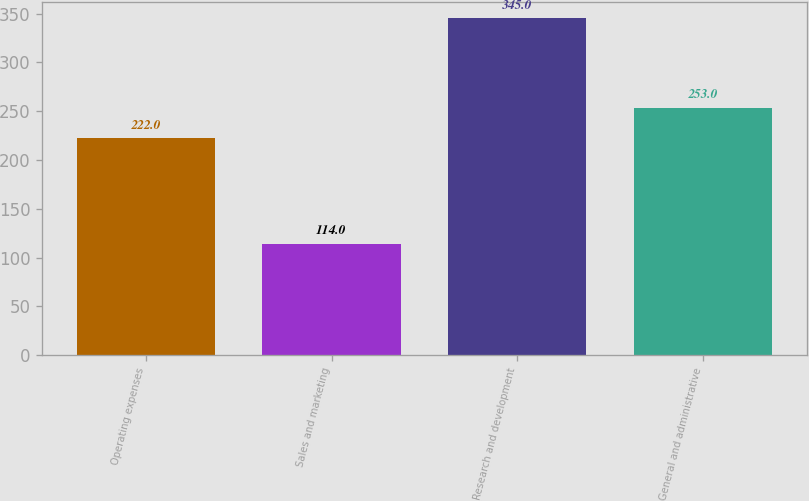Convert chart to OTSL. <chart><loc_0><loc_0><loc_500><loc_500><bar_chart><fcel>Operating expenses<fcel>Sales and marketing<fcel>Research and development<fcel>General and administrative<nl><fcel>222<fcel>114<fcel>345<fcel>253<nl></chart> 